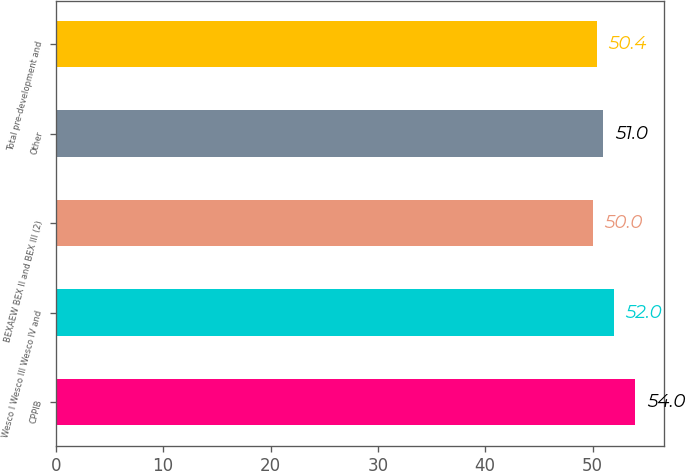Convert chart. <chart><loc_0><loc_0><loc_500><loc_500><bar_chart><fcel>CPPIB<fcel>Wesco I Wesco III Wesco IV and<fcel>BEXAEW BEX II and BEX III (2)<fcel>Other<fcel>Total pre-development and<nl><fcel>54<fcel>52<fcel>50<fcel>51<fcel>50.4<nl></chart> 